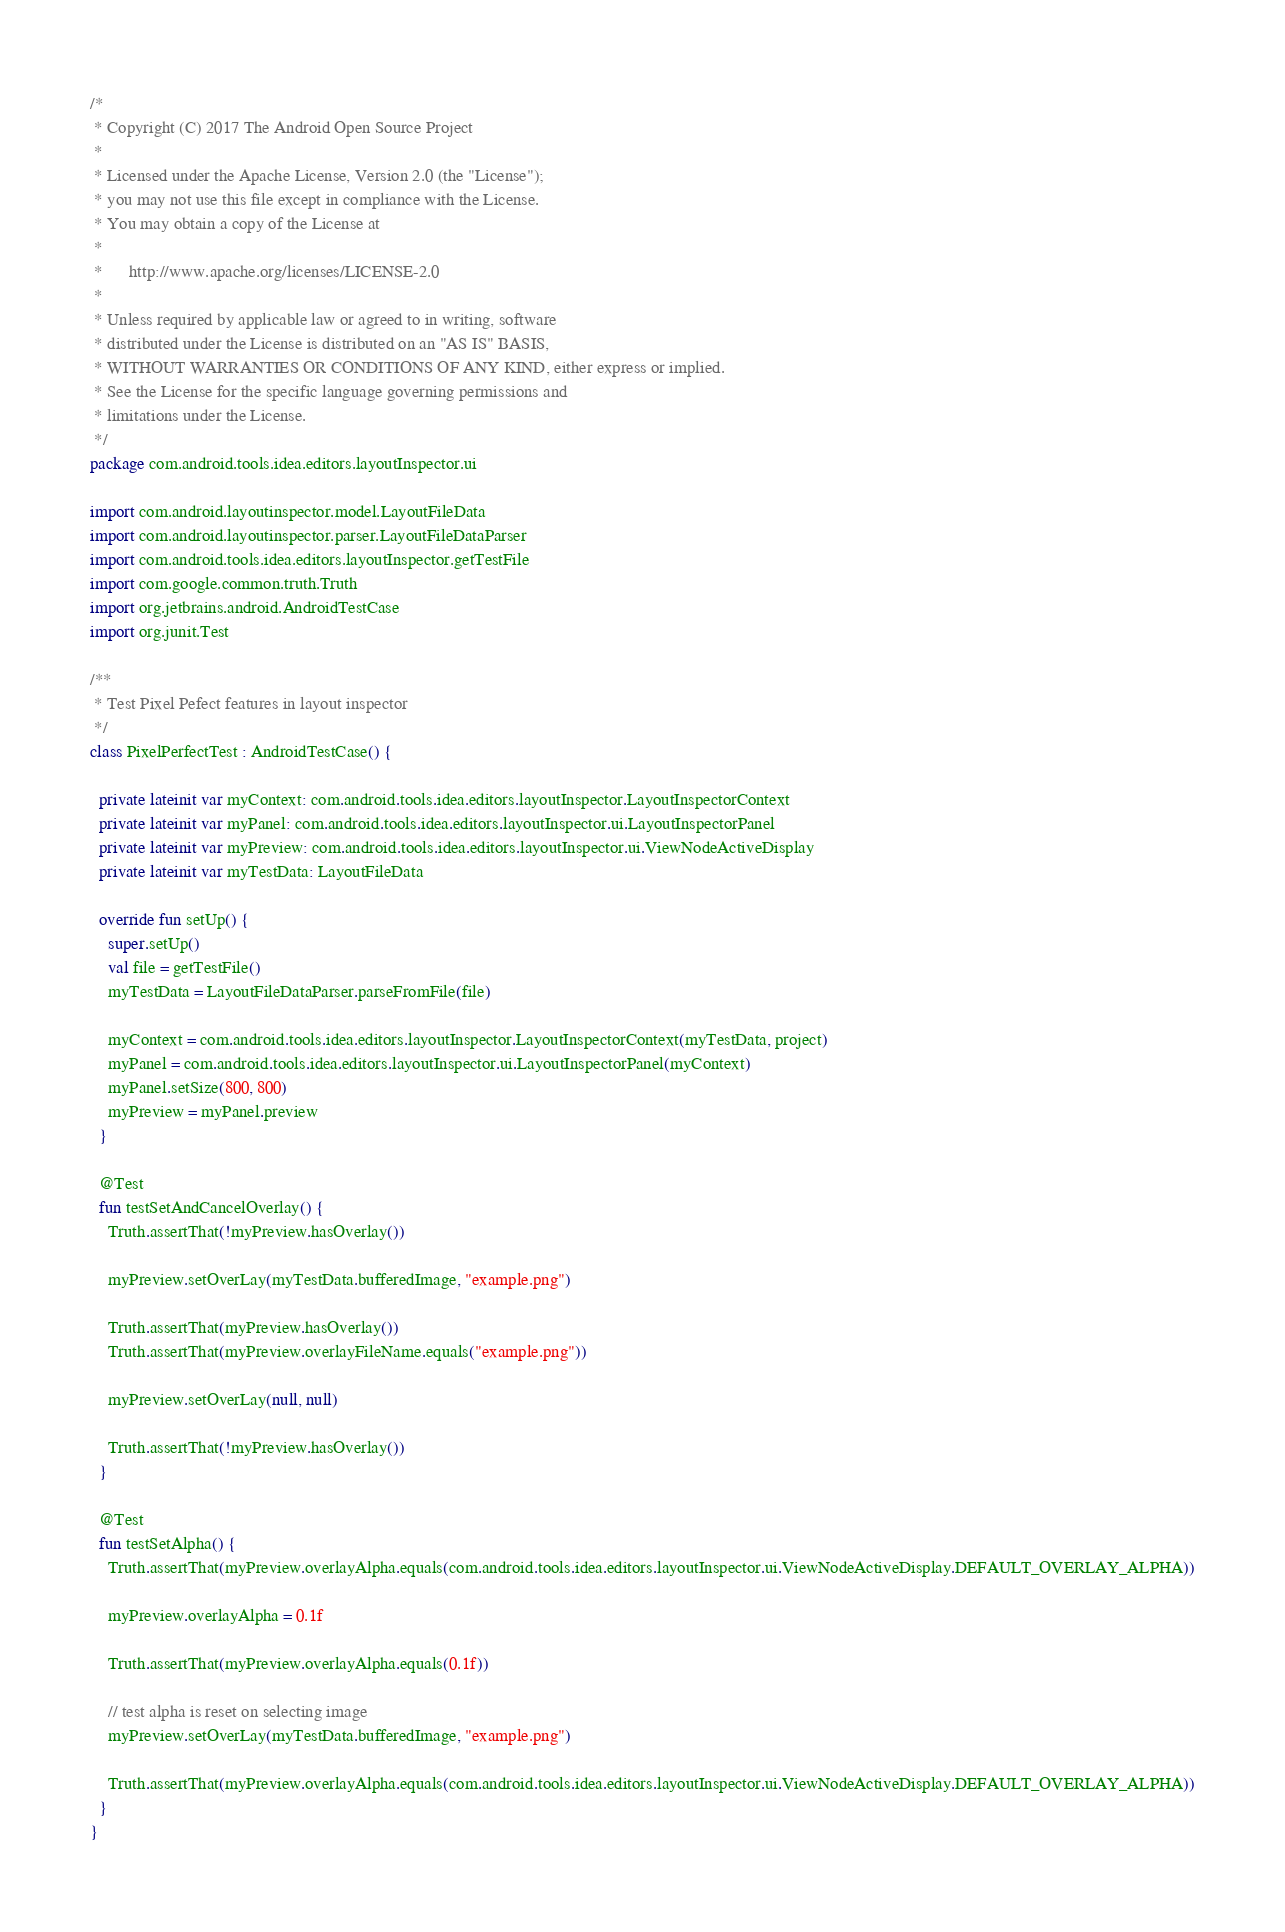<code> <loc_0><loc_0><loc_500><loc_500><_Kotlin_>/*
 * Copyright (C) 2017 The Android Open Source Project
 *
 * Licensed under the Apache License, Version 2.0 (the "License");
 * you may not use this file except in compliance with the License.
 * You may obtain a copy of the License at
 *
 *      http://www.apache.org/licenses/LICENSE-2.0
 *
 * Unless required by applicable law or agreed to in writing, software
 * distributed under the License is distributed on an "AS IS" BASIS,
 * WITHOUT WARRANTIES OR CONDITIONS OF ANY KIND, either express or implied.
 * See the License for the specific language governing permissions and
 * limitations under the License.
 */
package com.android.tools.idea.editors.layoutInspector.ui

import com.android.layoutinspector.model.LayoutFileData
import com.android.layoutinspector.parser.LayoutFileDataParser
import com.android.tools.idea.editors.layoutInspector.getTestFile
import com.google.common.truth.Truth
import org.jetbrains.android.AndroidTestCase
import org.junit.Test

/**
 * Test Pixel Pefect features in layout inspector
 */
class PixelPerfectTest : AndroidTestCase() {

  private lateinit var myContext: com.android.tools.idea.editors.layoutInspector.LayoutInspectorContext
  private lateinit var myPanel: com.android.tools.idea.editors.layoutInspector.ui.LayoutInspectorPanel
  private lateinit var myPreview: com.android.tools.idea.editors.layoutInspector.ui.ViewNodeActiveDisplay
  private lateinit var myTestData: LayoutFileData

  override fun setUp() {
    super.setUp()
    val file = getTestFile()
    myTestData = LayoutFileDataParser.parseFromFile(file)

    myContext = com.android.tools.idea.editors.layoutInspector.LayoutInspectorContext(myTestData, project)
    myPanel = com.android.tools.idea.editors.layoutInspector.ui.LayoutInspectorPanel(myContext)
    myPanel.setSize(800, 800)
    myPreview = myPanel.preview
  }

  @Test
  fun testSetAndCancelOverlay() {
    Truth.assertThat(!myPreview.hasOverlay())

    myPreview.setOverLay(myTestData.bufferedImage, "example.png")

    Truth.assertThat(myPreview.hasOverlay())
    Truth.assertThat(myPreview.overlayFileName.equals("example.png"))

    myPreview.setOverLay(null, null)

    Truth.assertThat(!myPreview.hasOverlay())
  }

  @Test
  fun testSetAlpha() {
    Truth.assertThat(myPreview.overlayAlpha.equals(com.android.tools.idea.editors.layoutInspector.ui.ViewNodeActiveDisplay.DEFAULT_OVERLAY_ALPHA))

    myPreview.overlayAlpha = 0.1f

    Truth.assertThat(myPreview.overlayAlpha.equals(0.1f))

    // test alpha is reset on selecting image
    myPreview.setOverLay(myTestData.bufferedImage, "example.png")

    Truth.assertThat(myPreview.overlayAlpha.equals(com.android.tools.idea.editors.layoutInspector.ui.ViewNodeActiveDisplay.DEFAULT_OVERLAY_ALPHA))
  }
}
</code> 